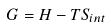Convert formula to latex. <formula><loc_0><loc_0><loc_500><loc_500>G = H - T S _ { i n t }</formula> 